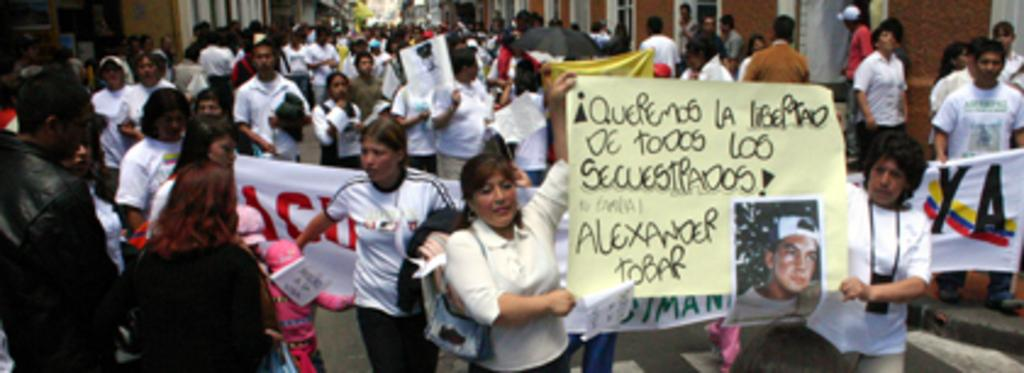What is the main subject of the image? The main subject of the image is a crowd. Where is the crowd located in the image? The crowd is between buildings. What are some of the people in the crowd doing? Some persons in the crowd are holding banners. What type of crook can be seen in the image? There is no crook present in the image. What is the stem of the plant doing in the image? There is no plant or stem present in the image. 